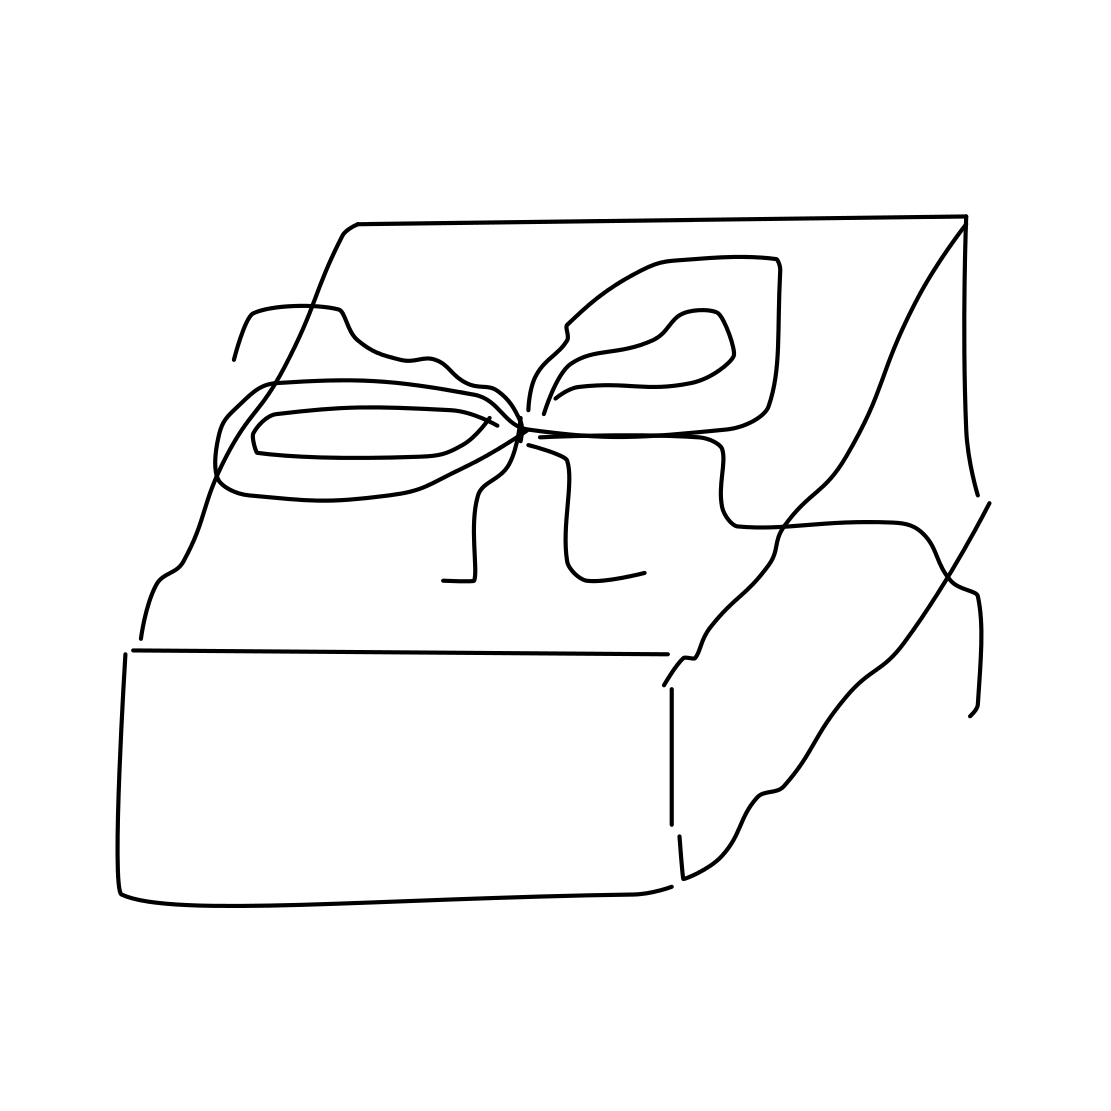Could you describe the type of wrapping used on the present? The wrapping appears quite simple yet elegant. It features a smooth, unembellished paper topped with a neatly tied bow. The choice of minimalistic design could imply a sophisticated taste or a preference for understated elegance. 